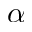Convert formula to latex. <formula><loc_0><loc_0><loc_500><loc_500>\alpha</formula> 